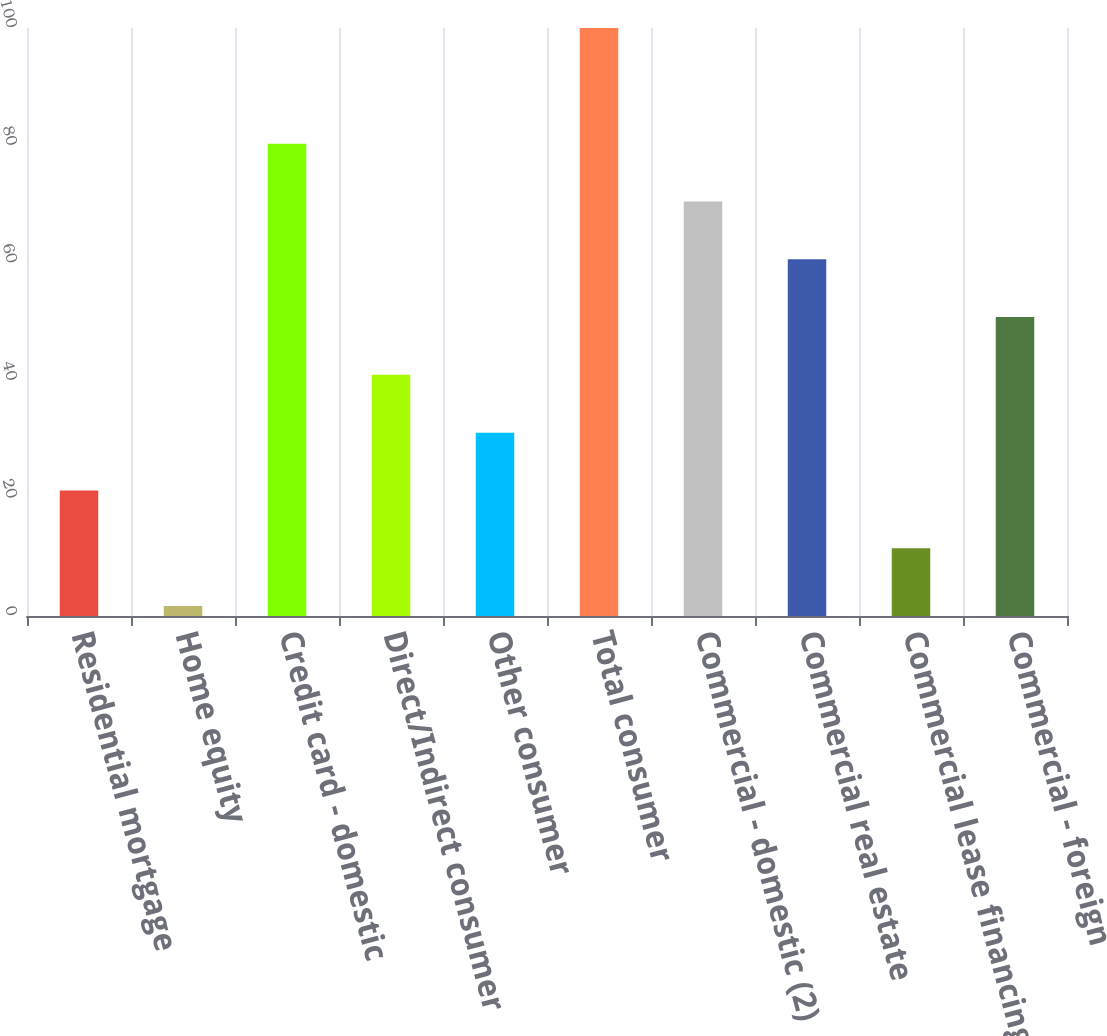Convert chart. <chart><loc_0><loc_0><loc_500><loc_500><bar_chart><fcel>Residential mortgage<fcel>Home equity<fcel>Credit card - domestic<fcel>Direct/Indirect consumer<fcel>Other consumer<fcel>Total consumer<fcel>Commercial - domestic (2)<fcel>Commercial real estate<fcel>Commercial lease financing<fcel>Commercial - foreign<nl><fcel>21.35<fcel>1.69<fcel>80.33<fcel>41.01<fcel>31.18<fcel>99.99<fcel>70.5<fcel>60.67<fcel>11.52<fcel>50.84<nl></chart> 